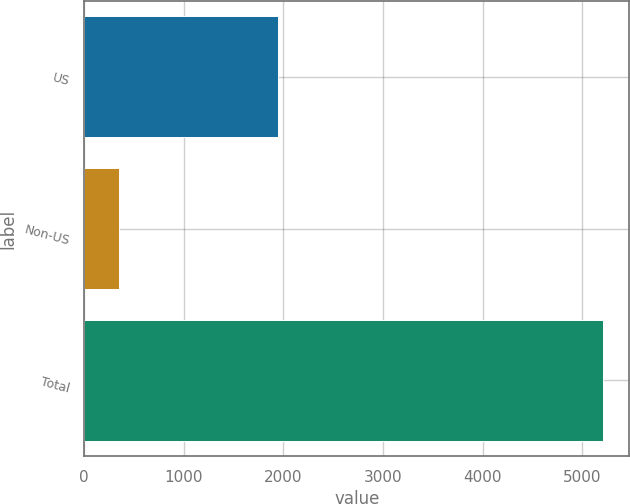Convert chart. <chart><loc_0><loc_0><loc_500><loc_500><bar_chart><fcel>US<fcel>Non-US<fcel>Total<nl><fcel>1948<fcel>344<fcel>5209<nl></chart> 